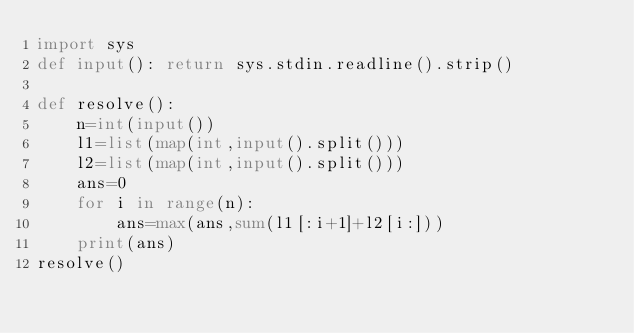Convert code to text. <code><loc_0><loc_0><loc_500><loc_500><_Python_>import sys
def input(): return sys.stdin.readline().strip()

def resolve():
    n=int(input())
    l1=list(map(int,input().split()))
    l2=list(map(int,input().split()))
    ans=0
    for i in range(n):
        ans=max(ans,sum(l1[:i+1]+l2[i:]))
    print(ans)
resolve()</code> 